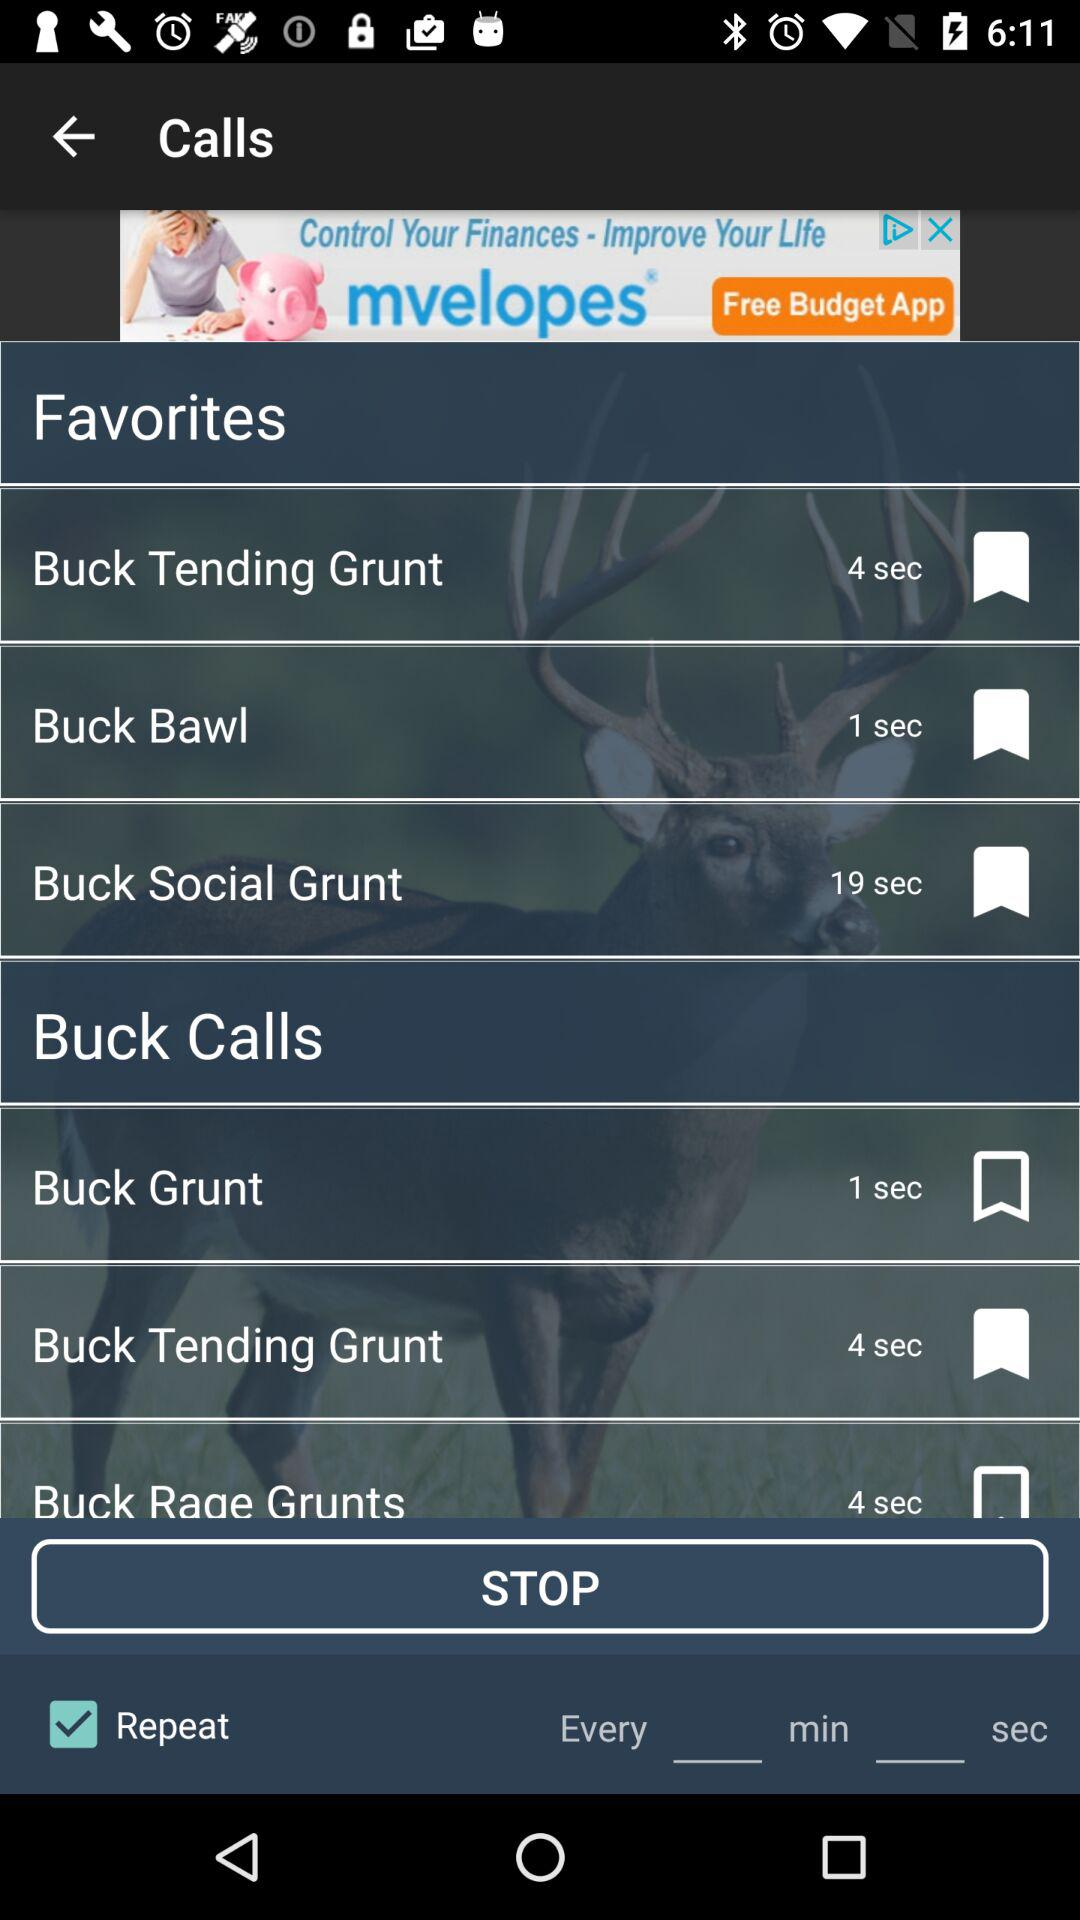How many seconds longer is Buck Rage Grunts than Buck Grunt?
Answer the question using a single word or phrase. 3 